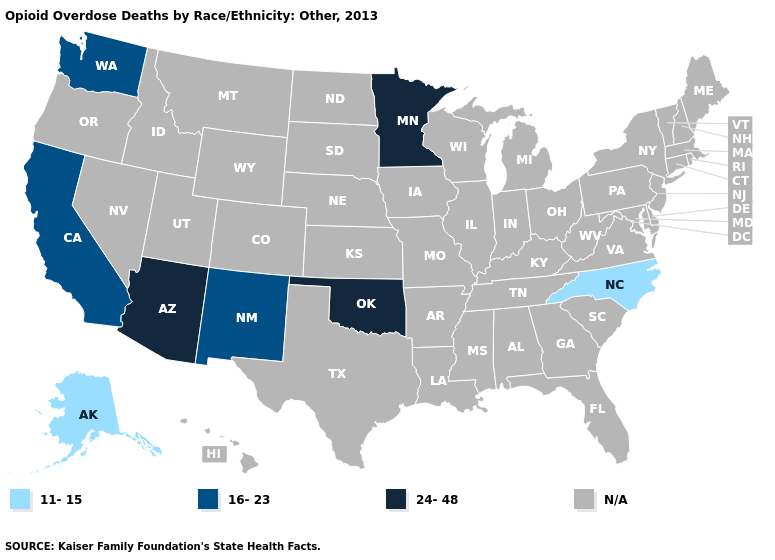Name the states that have a value in the range N/A?
Give a very brief answer. Alabama, Arkansas, Colorado, Connecticut, Delaware, Florida, Georgia, Hawaii, Idaho, Illinois, Indiana, Iowa, Kansas, Kentucky, Louisiana, Maine, Maryland, Massachusetts, Michigan, Mississippi, Missouri, Montana, Nebraska, Nevada, New Hampshire, New Jersey, New York, North Dakota, Ohio, Oregon, Pennsylvania, Rhode Island, South Carolina, South Dakota, Tennessee, Texas, Utah, Vermont, Virginia, West Virginia, Wisconsin, Wyoming. Which states hav the highest value in the West?
Concise answer only. Arizona. Does Alaska have the highest value in the USA?
Concise answer only. No. What is the value of South Dakota?
Answer briefly. N/A. Does the map have missing data?
Concise answer only. Yes. What is the value of South Dakota?
Keep it brief. N/A. Name the states that have a value in the range 11-15?
Write a very short answer. Alaska, North Carolina. Name the states that have a value in the range 16-23?
Short answer required. California, New Mexico, Washington. Does Alaska have the lowest value in the USA?
Give a very brief answer. Yes. Name the states that have a value in the range N/A?
Concise answer only. Alabama, Arkansas, Colorado, Connecticut, Delaware, Florida, Georgia, Hawaii, Idaho, Illinois, Indiana, Iowa, Kansas, Kentucky, Louisiana, Maine, Maryland, Massachusetts, Michigan, Mississippi, Missouri, Montana, Nebraska, Nevada, New Hampshire, New Jersey, New York, North Dakota, Ohio, Oregon, Pennsylvania, Rhode Island, South Carolina, South Dakota, Tennessee, Texas, Utah, Vermont, Virginia, West Virginia, Wisconsin, Wyoming. What is the lowest value in the USA?
Concise answer only. 11-15. Name the states that have a value in the range N/A?
Answer briefly. Alabama, Arkansas, Colorado, Connecticut, Delaware, Florida, Georgia, Hawaii, Idaho, Illinois, Indiana, Iowa, Kansas, Kentucky, Louisiana, Maine, Maryland, Massachusetts, Michigan, Mississippi, Missouri, Montana, Nebraska, Nevada, New Hampshire, New Jersey, New York, North Dakota, Ohio, Oregon, Pennsylvania, Rhode Island, South Carolina, South Dakota, Tennessee, Texas, Utah, Vermont, Virginia, West Virginia, Wisconsin, Wyoming. Name the states that have a value in the range 24-48?
Quick response, please. Arizona, Minnesota, Oklahoma. 